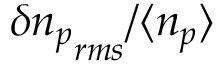<formula> <loc_0><loc_0><loc_500><loc_500>\delta { n _ { p } } _ { r m s } / \langle n _ { p } \rangle</formula> 